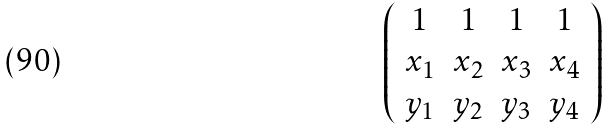Convert formula to latex. <formula><loc_0><loc_0><loc_500><loc_500>\left ( \begin{array} { c c c c } 1 & 1 & 1 & 1 \\ x _ { 1 } & x _ { 2 } & x _ { 3 } & x _ { 4 } \\ y _ { 1 } & y _ { 2 } & y _ { 3 } & y _ { 4 } \end{array} \right )</formula> 